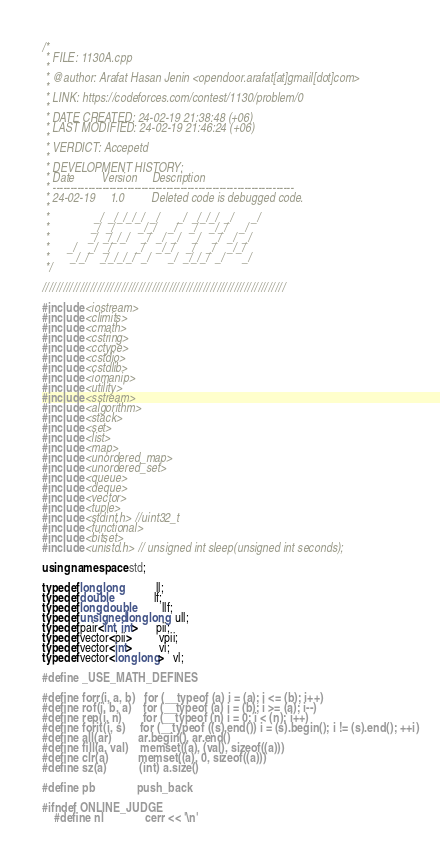<code> <loc_0><loc_0><loc_500><loc_500><_C++_>/*
 * FILE: 1130A.cpp
 *
 * @author: Arafat Hasan Jenin <opendoor.arafat[at]gmail[dot]com>
 *
 * LINK: https://codeforces.com/contest/1130/problem/0
 *
 * DATE CREATED: 24-02-19 21:38:48 (+06)
 * LAST MODIFIED: 24-02-19 21:46:24 (+06)
 *
 * VERDICT: Accepetd
 *
 * DEVELOPMENT HISTORY:
 * Date         Version     Description
 * --------------------------------------------------------------------
 * 24-02-19     1.0         Deleted code is debugged code.
 *
 *               _/  _/_/_/_/  _/      _/  _/_/_/  _/      _/
 *              _/  _/        _/_/    _/    _/    _/_/    _/
 *             _/  _/_/_/    _/  _/  _/    _/    _/  _/  _/
 *      _/    _/  _/        _/    _/_/    _/    _/    _/_/
 *       _/_/    _/_/_/_/  _/      _/  _/_/_/  _/      _/
 */

///////////////////////////////////////////////////////////////////////

#include <iostream>
#include <climits>
#include <cmath>
#include <cstring>
#include <cctype>
#include <cstdio>
#include <cstdlib>
#include <iomanip>
#include <utility>
#include <sstream>
#include <algorithm>
#include <stack>
#include <set>
#include <list>
#include <map>
#include <unordered_map>
#include <unordered_set>
#include <queue>
#include <deque>
#include <vector>
#include <tuple>
#include <stdint.h> //uint32_t
#include <functional>
#include <bitset>
#include <unistd.h> // unsigned int sleep(unsigned int seconds);

using namespace std;

typedef long long           ll;
typedef double              lf;
typedef long double         llf;
typedef unsigned long long  ull;
typedef pair<int, int>      pii;
typedef vector<pii>         vpii;
typedef vector<int>         vi;
typedef vector<long long>   vl;

#define _USE_MATH_DEFINES

#define forr(i, a, b)   for (__typeof (a) i = (a); i <= (b); i++)
#define rof(i, b, a)    for (__typeof (a) i = (b); i >= (a); i--)
#define rep(i, n)       for (__typeof (n) i = 0; i < (n); i++)
#define forit(i, s)     for (__typeof ((s).end()) i = (s).begin(); i != (s).end(); ++i)
#define all(ar)         ar.begin(), ar.end()
#define fill(a, val)    memset((a), (val), sizeof((a)))
#define clr(a)          memset((a), 0, sizeof((a)))
#define sz(a)           (int) a.size()

#define pb              push_back

#ifndef ONLINE_JUDGE
    #define nl              cerr << '\n'</code> 